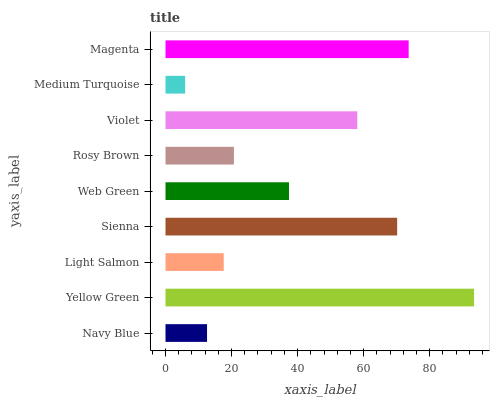Is Medium Turquoise the minimum?
Answer yes or no. Yes. Is Yellow Green the maximum?
Answer yes or no. Yes. Is Light Salmon the minimum?
Answer yes or no. No. Is Light Salmon the maximum?
Answer yes or no. No. Is Yellow Green greater than Light Salmon?
Answer yes or no. Yes. Is Light Salmon less than Yellow Green?
Answer yes or no. Yes. Is Light Salmon greater than Yellow Green?
Answer yes or no. No. Is Yellow Green less than Light Salmon?
Answer yes or no. No. Is Web Green the high median?
Answer yes or no. Yes. Is Web Green the low median?
Answer yes or no. Yes. Is Medium Turquoise the high median?
Answer yes or no. No. Is Magenta the low median?
Answer yes or no. No. 